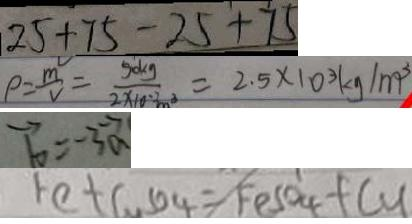Convert formula to latex. <formula><loc_0><loc_0><loc_500><loc_500>2 5 + 7 5 - 2 5 + 7 5 
 \rho = \frac { m } { V } = \frac { 5 0 k g } { 2 \times 1 0 ^ { - 2 } m ^ { 3 } } = 2 . 5 \times 1 0 ^ { 3 } k g / m ^ { 3 } 
 \overrightarrow { b } = - 3 \overrightarrow { a } 
 F e + C u S O _ { 4 } = F e S O _ { 4 } + C u</formula> 